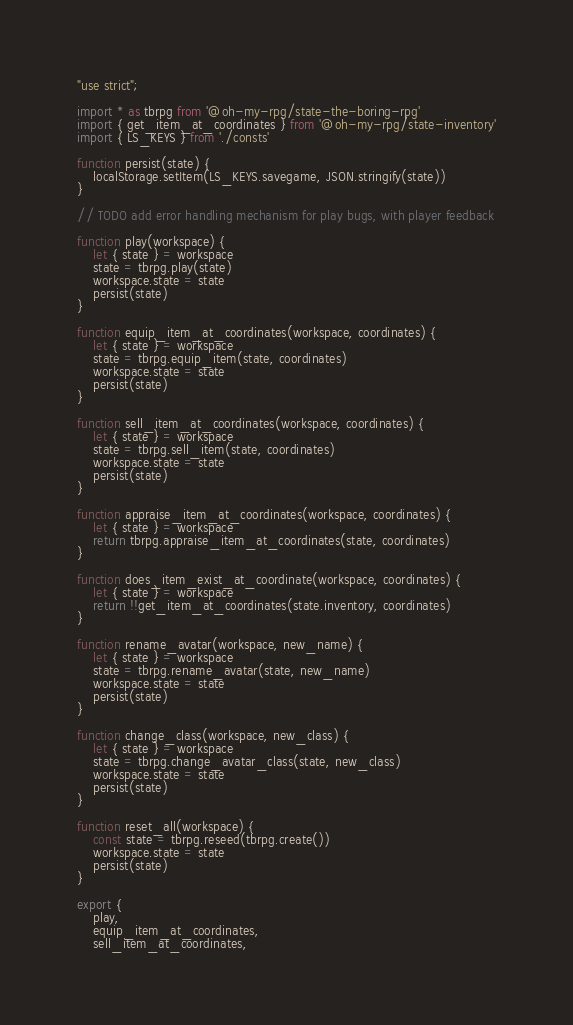Convert code to text. <code><loc_0><loc_0><loc_500><loc_500><_JavaScript_>"use strict";

import * as tbrpg from '@oh-my-rpg/state-the-boring-rpg'
import { get_item_at_coordinates } from '@oh-my-rpg/state-inventory'
import { LS_KEYS } from './consts'

function persist(state) {
	localStorage.setItem(LS_KEYS.savegame, JSON.stringify(state))
}

// TODO add error handling mechanism for play bugs, with player feedback

function play(workspace) {
	let { state } = workspace
	state = tbrpg.play(state)
	workspace.state = state
	persist(state)
}

function equip_item_at_coordinates(workspace, coordinates) {
	let { state } = workspace
	state = tbrpg.equip_item(state, coordinates)
	workspace.state = state
	persist(state)
}

function sell_item_at_coordinates(workspace, coordinates) {
	let { state } = workspace
	state = tbrpg.sell_item(state, coordinates)
	workspace.state = state
	persist(state)
}

function appraise_item_at_coordinates(workspace, coordinates) {
	let { state } = workspace
	return tbrpg.appraise_item_at_coordinates(state, coordinates)
}

function does_item_exist_at_coordinate(workspace, coordinates) {
	let { state } = workspace
	return !!get_item_at_coordinates(state.inventory, coordinates)
}

function rename_avatar(workspace, new_name) {
	let { state } = workspace
	state = tbrpg.rename_avatar(state, new_name)
	workspace.state = state
	persist(state)
}

function change_class(workspace, new_class) {
	let { state } = workspace
	state = tbrpg.change_avatar_class(state, new_class)
	workspace.state = state
	persist(state)
}

function reset_all(workspace) {
	const state = tbrpg.reseed(tbrpg.create())
	workspace.state = state
	persist(state)
}

export {
	play,
	equip_item_at_coordinates,
	sell_item_at_coordinates,</code> 